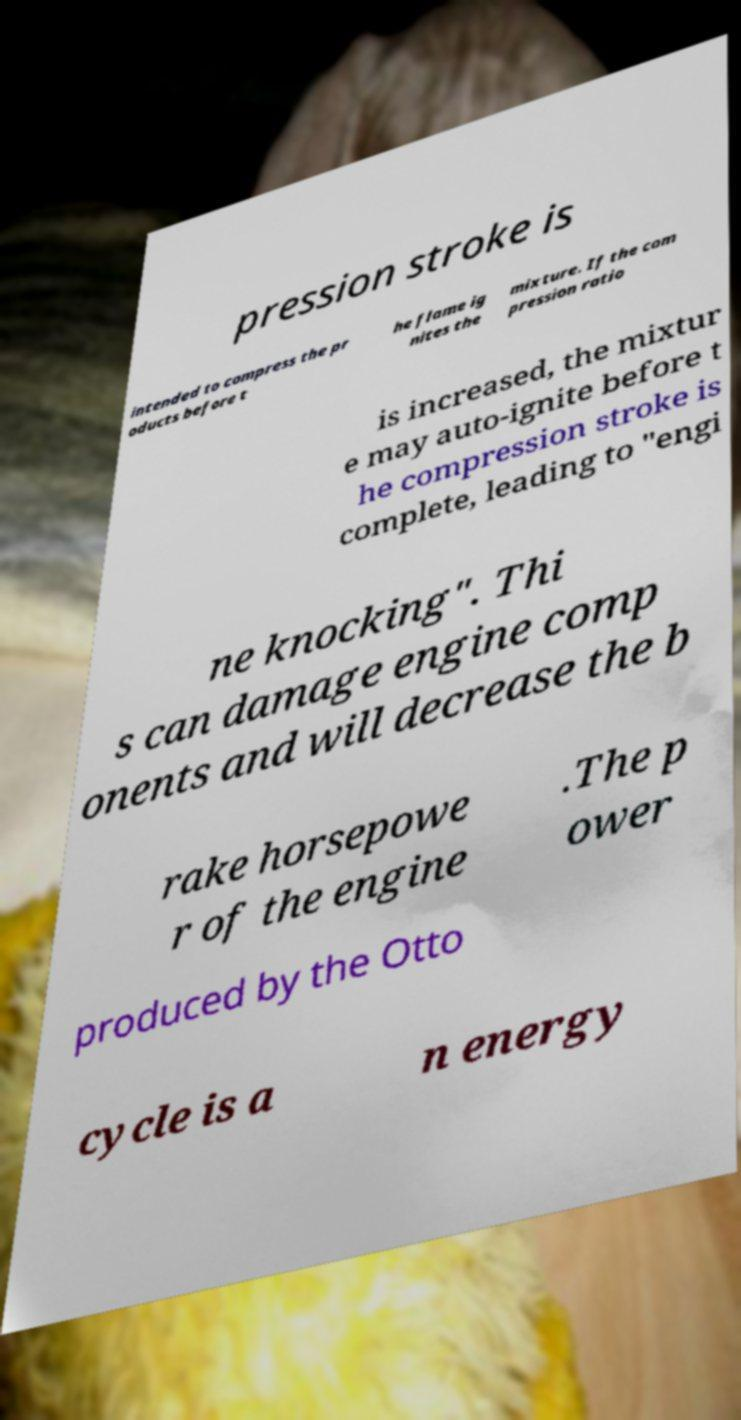I need the written content from this picture converted into text. Can you do that? pression stroke is intended to compress the pr oducts before t he flame ig nites the mixture. If the com pression ratio is increased, the mixtur e may auto-ignite before t he compression stroke is complete, leading to "engi ne knocking". Thi s can damage engine comp onents and will decrease the b rake horsepowe r of the engine .The p ower produced by the Otto cycle is a n energy 